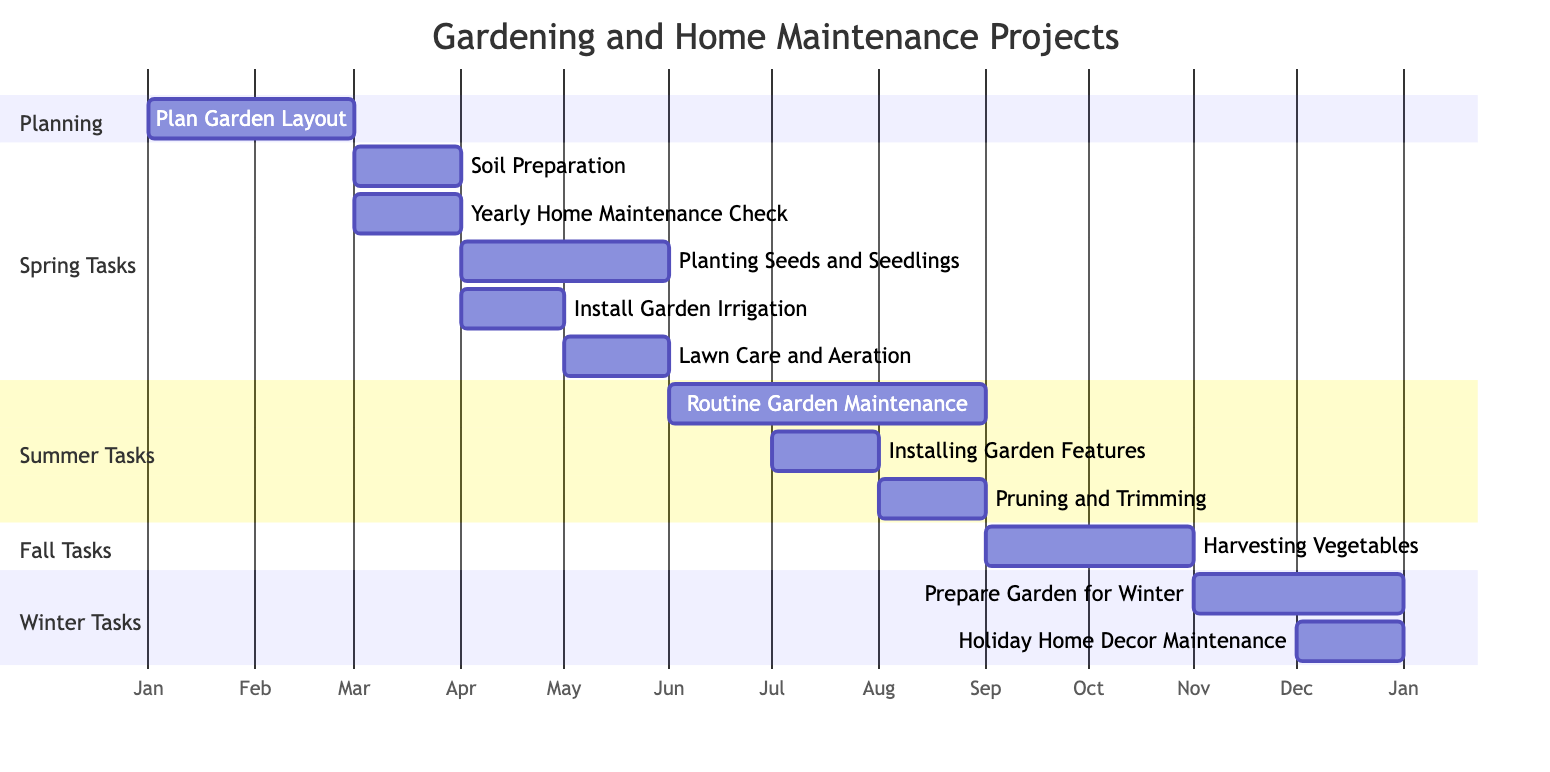What is the total number of tasks in the Gantt Chart? By counting each listed task in the Gantt Chart, I see there are 12 distinct tasks presented throughout the four seasons.
Answer: 12 During which month does the "Soil Preparation" task take place? Referring to the Gantt Chart, the "Soil Preparation" task is scheduled for March, as indicated on the timeline.
Answer: March How many months does "Routine Garden Maintenance" span? The "Routine Garden Maintenance" task covers three months, from June to August, as indicated by the length of the bar in the Gantt Chart.
Answer: 3 months What task immediately follows "Lawn Care and Aeration"? Looking at the timeline, after "Lawn Care and Aeration" in May, the next scheduled task is "Routine Garden Maintenance," which begins in June.
Answer: Routine Garden Maintenance In which season is "Preparing Garden for Winter" scheduled? By checking the Gantt Chart sections, "Preparing Garden for Winter" is categorized under the Winter Tasks section, showing it is planned for November to December.
Answer: Winter How many tasks are planned for the month of April? From the Gantt Chart, I can see that there are two tasks scheduled for April: "Planting Seeds and Seedlings" and "Install Garden Irrigation."
Answer: 2 tasks Which task is the last one to be performed in the year? According to the chart, "Holiday Home Decor Maintenance" is the last task in December, thus marking the end of the yearly schedule.
Answer: Holiday Home Decor Maintenance Is there any task scheduled for February? Upon examining the chart, no tasks are shown for February; the last task in January is "Plan Garden Layout," which ends in that month.
Answer: No What is the duration of the "Harvesting Vegetables" task? The task "Harvesting Vegetables" lasts for two months, from September to October, as per the Gantt Chart timeline.
Answer: 2 months 